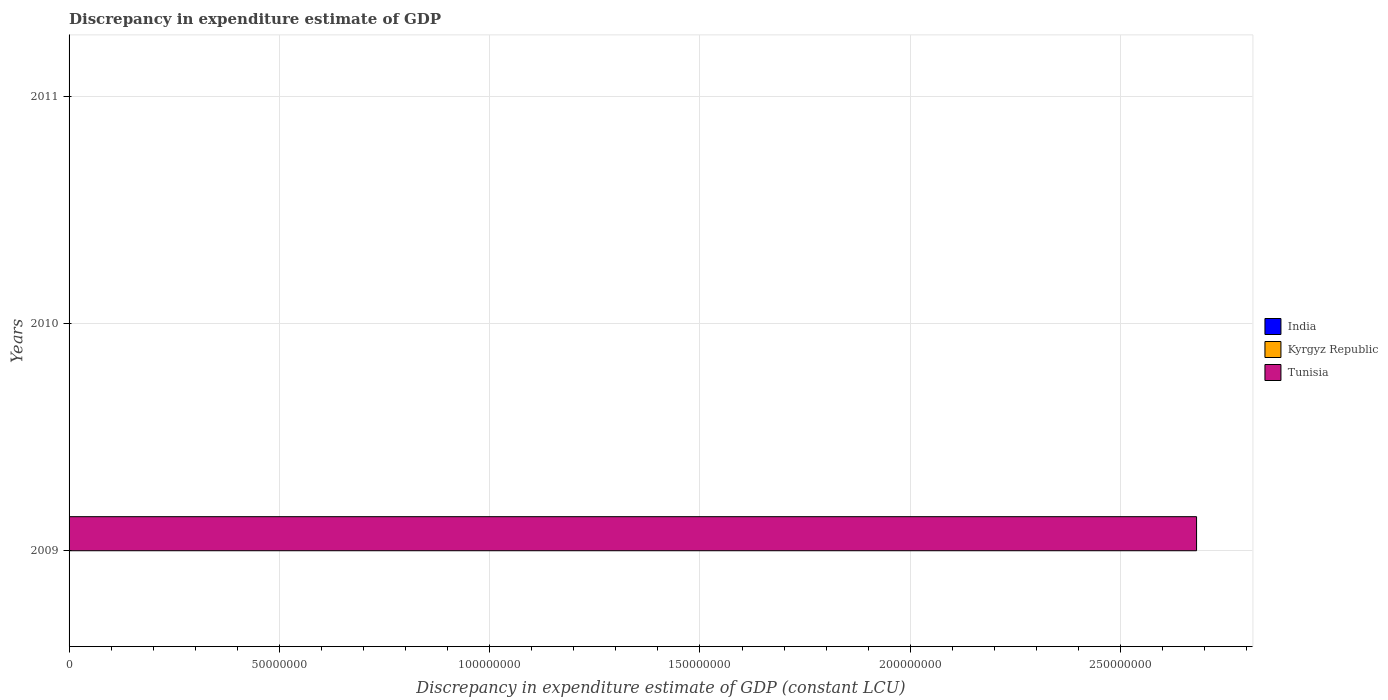Are the number of bars per tick equal to the number of legend labels?
Make the answer very short. No. Are the number of bars on each tick of the Y-axis equal?
Provide a short and direct response. No. How many bars are there on the 2nd tick from the top?
Give a very brief answer. 0. Across all years, what is the maximum discrepancy in expenditure estimate of GDP in Tunisia?
Give a very brief answer. 2.68e+08. Across all years, what is the minimum discrepancy in expenditure estimate of GDP in Kyrgyz Republic?
Give a very brief answer. 0. In which year was the discrepancy in expenditure estimate of GDP in Tunisia maximum?
Offer a terse response. 2009. What is the difference between the discrepancy in expenditure estimate of GDP in Tunisia in 2009 and the discrepancy in expenditure estimate of GDP in Kyrgyz Republic in 2011?
Give a very brief answer. 2.68e+08. In how many years, is the discrepancy in expenditure estimate of GDP in India greater than 270000000 LCU?
Make the answer very short. 0. What is the difference between the highest and the lowest discrepancy in expenditure estimate of GDP in Tunisia?
Your answer should be very brief. 2.68e+08. Is it the case that in every year, the sum of the discrepancy in expenditure estimate of GDP in Tunisia and discrepancy in expenditure estimate of GDP in India is greater than the discrepancy in expenditure estimate of GDP in Kyrgyz Republic?
Your response must be concise. No. How many years are there in the graph?
Offer a very short reply. 3. Are the values on the major ticks of X-axis written in scientific E-notation?
Offer a very short reply. No. Does the graph contain grids?
Offer a terse response. Yes. Where does the legend appear in the graph?
Offer a terse response. Center right. How many legend labels are there?
Ensure brevity in your answer.  3. How are the legend labels stacked?
Make the answer very short. Vertical. What is the title of the graph?
Give a very brief answer. Discrepancy in expenditure estimate of GDP. What is the label or title of the X-axis?
Ensure brevity in your answer.  Discrepancy in expenditure estimate of GDP (constant LCU). What is the Discrepancy in expenditure estimate of GDP (constant LCU) of India in 2009?
Make the answer very short. 0. What is the Discrepancy in expenditure estimate of GDP (constant LCU) in Tunisia in 2009?
Offer a very short reply. 2.68e+08. What is the Discrepancy in expenditure estimate of GDP (constant LCU) of India in 2010?
Ensure brevity in your answer.  0. What is the Discrepancy in expenditure estimate of GDP (constant LCU) of Tunisia in 2010?
Provide a succinct answer. 0. What is the Discrepancy in expenditure estimate of GDP (constant LCU) in India in 2011?
Provide a short and direct response. 0. Across all years, what is the maximum Discrepancy in expenditure estimate of GDP (constant LCU) of Tunisia?
Give a very brief answer. 2.68e+08. Across all years, what is the minimum Discrepancy in expenditure estimate of GDP (constant LCU) in Tunisia?
Provide a short and direct response. 0. What is the total Discrepancy in expenditure estimate of GDP (constant LCU) in Kyrgyz Republic in the graph?
Provide a succinct answer. 0. What is the total Discrepancy in expenditure estimate of GDP (constant LCU) in Tunisia in the graph?
Give a very brief answer. 2.68e+08. What is the average Discrepancy in expenditure estimate of GDP (constant LCU) of Kyrgyz Republic per year?
Your answer should be very brief. 0. What is the average Discrepancy in expenditure estimate of GDP (constant LCU) in Tunisia per year?
Offer a terse response. 8.94e+07. What is the difference between the highest and the lowest Discrepancy in expenditure estimate of GDP (constant LCU) of Tunisia?
Your response must be concise. 2.68e+08. 